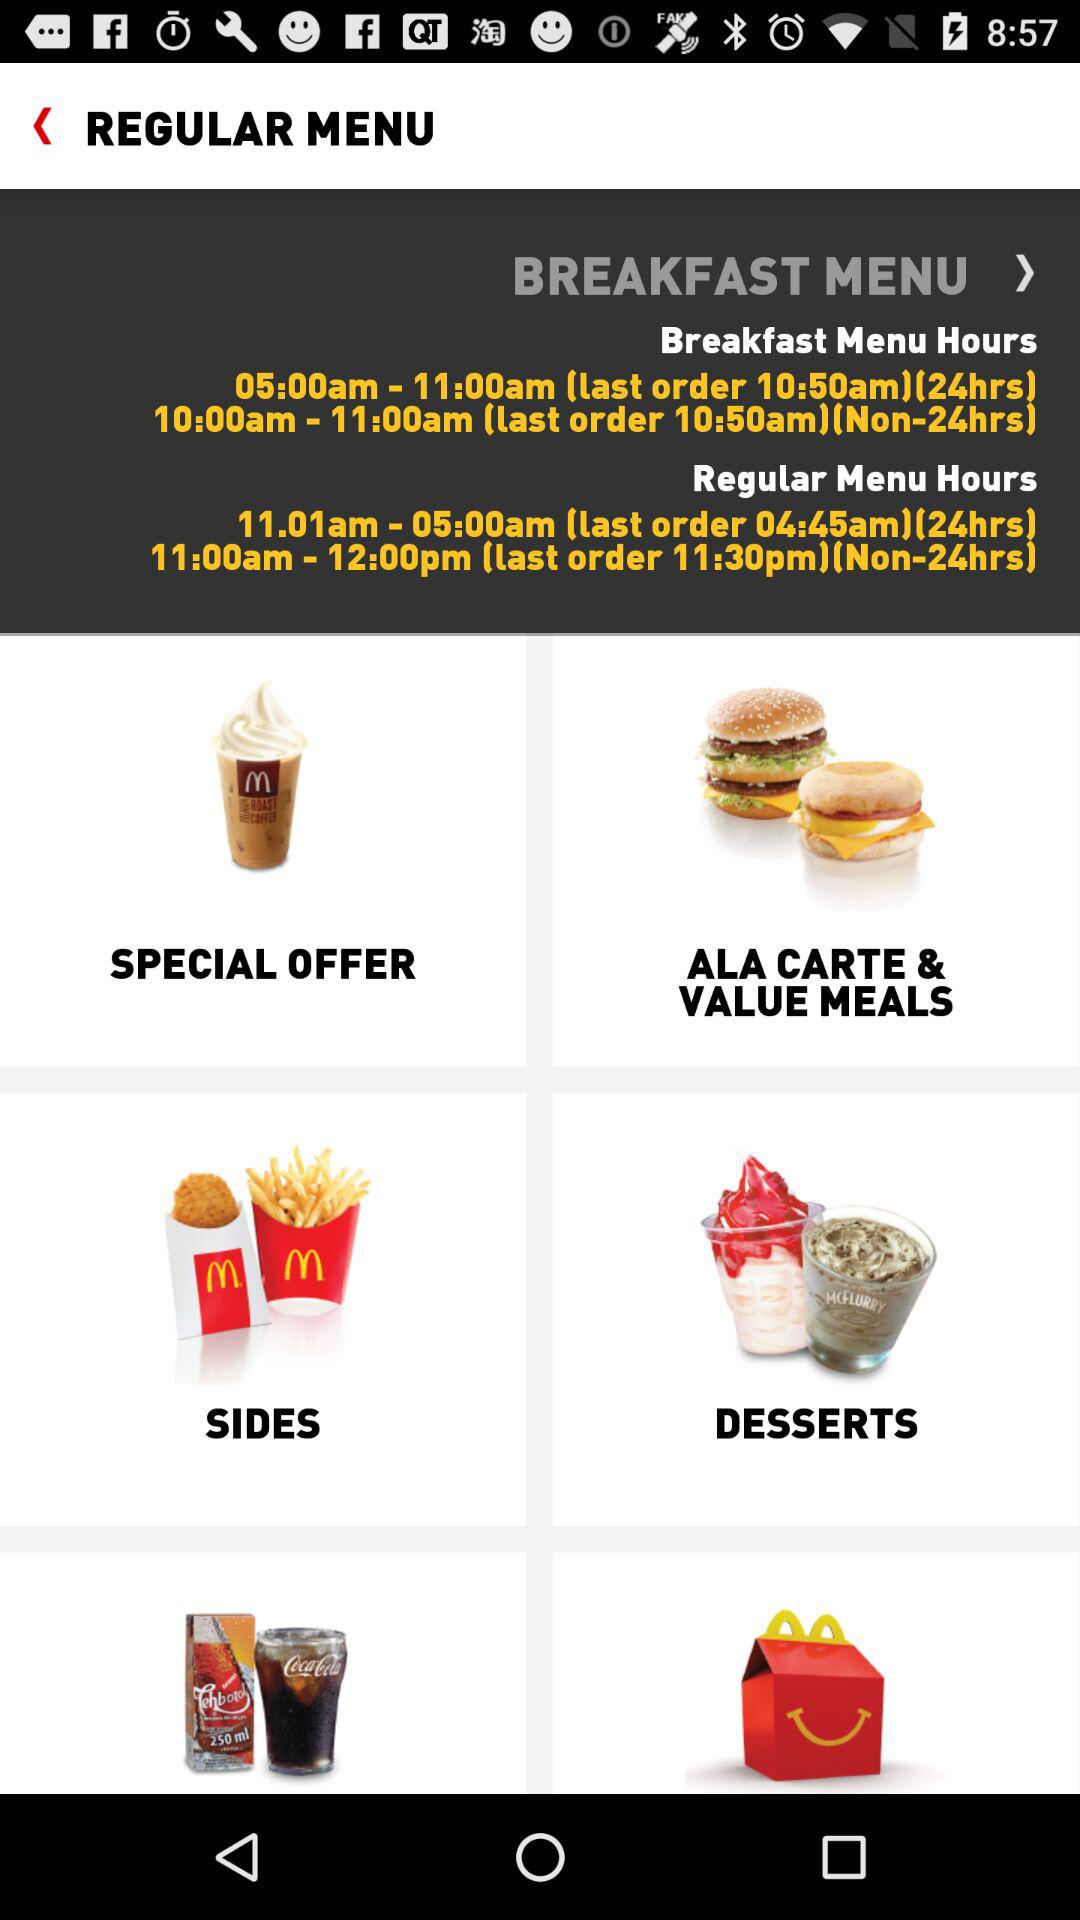What are the regular menu hours? The regular menu hours are 11:01 am - 05:00 am (last order 04:45 am)(24hrs) and 11:00 am - 12:00 pm (last order 11:30 pm)(Non-24hrs). 